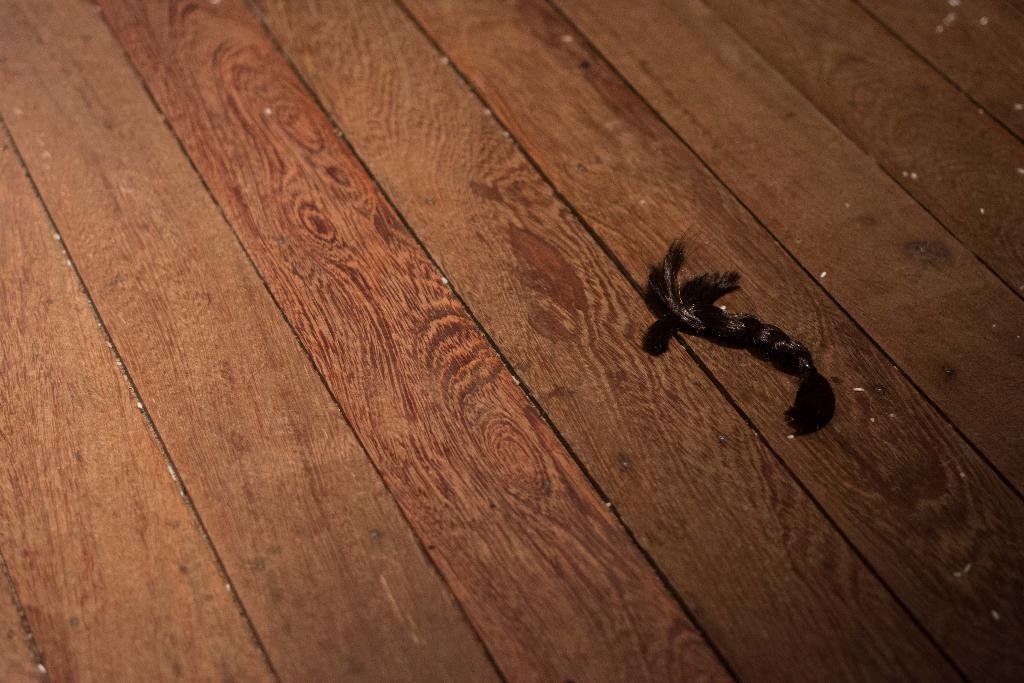Please provide a concise description of this image. In this image we can see deer fly on the table. 